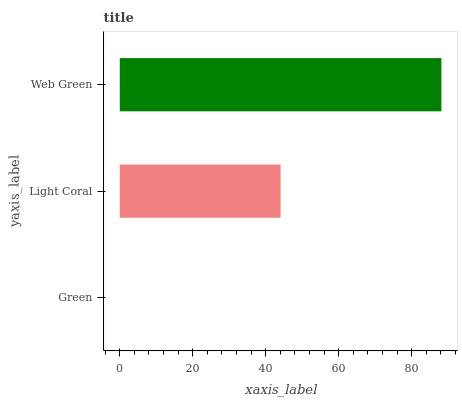Is Green the minimum?
Answer yes or no. Yes. Is Web Green the maximum?
Answer yes or no. Yes. Is Light Coral the minimum?
Answer yes or no. No. Is Light Coral the maximum?
Answer yes or no. No. Is Light Coral greater than Green?
Answer yes or no. Yes. Is Green less than Light Coral?
Answer yes or no. Yes. Is Green greater than Light Coral?
Answer yes or no. No. Is Light Coral less than Green?
Answer yes or no. No. Is Light Coral the high median?
Answer yes or no. Yes. Is Light Coral the low median?
Answer yes or no. Yes. Is Web Green the high median?
Answer yes or no. No. Is Web Green the low median?
Answer yes or no. No. 